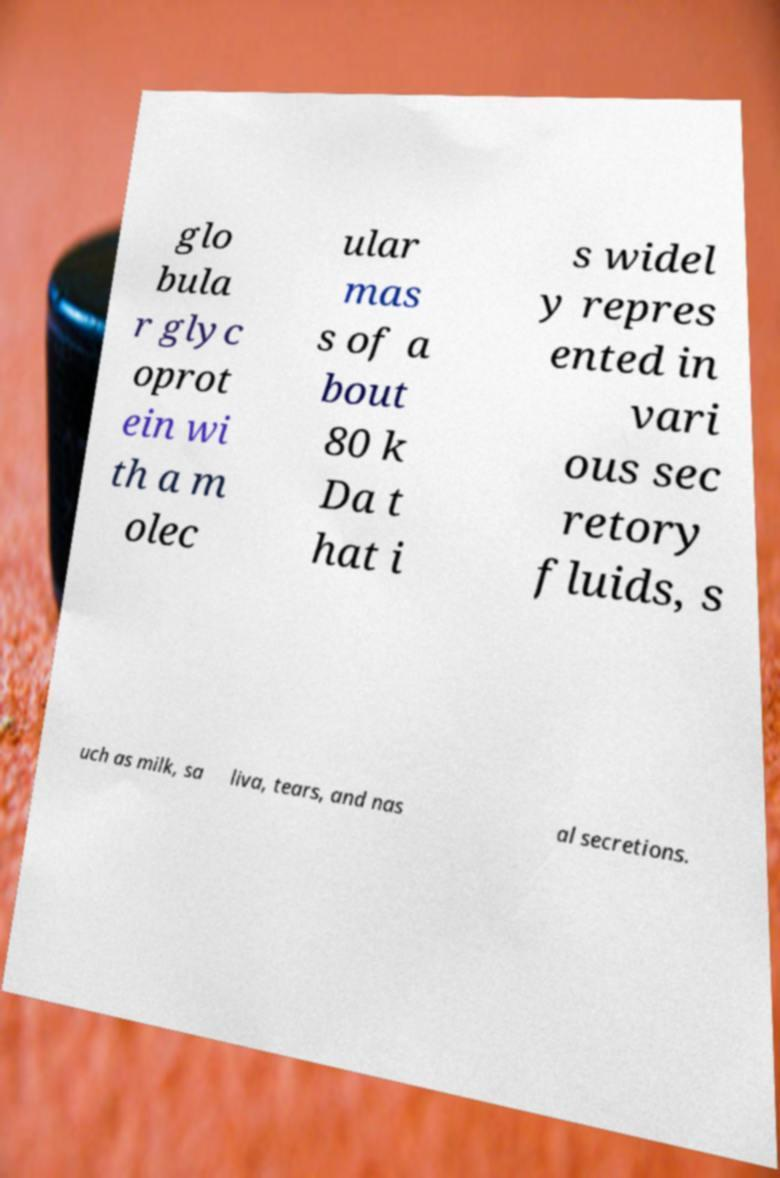Please read and relay the text visible in this image. What does it say? glo bula r glyc oprot ein wi th a m olec ular mas s of a bout 80 k Da t hat i s widel y repres ented in vari ous sec retory fluids, s uch as milk, sa liva, tears, and nas al secretions. 